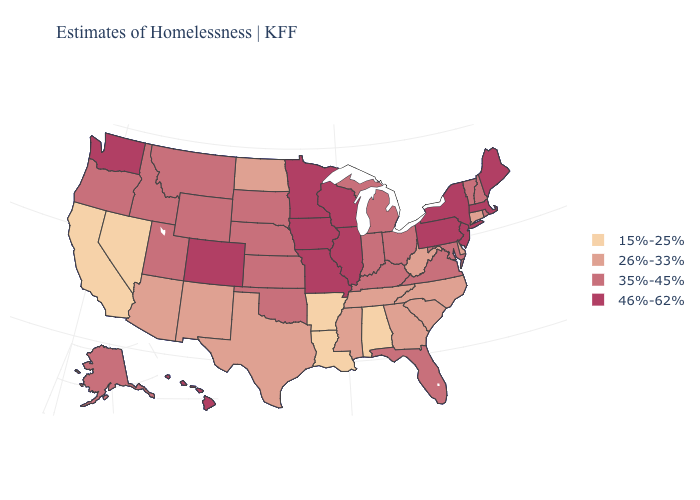Does the first symbol in the legend represent the smallest category?
Be succinct. Yes. What is the value of Delaware?
Concise answer only. 26%-33%. Does the first symbol in the legend represent the smallest category?
Answer briefly. Yes. Name the states that have a value in the range 26%-33%?
Quick response, please. Arizona, Connecticut, Delaware, Georgia, Mississippi, New Mexico, North Carolina, North Dakota, South Carolina, Tennessee, Texas, West Virginia. What is the value of Ohio?
Write a very short answer. 35%-45%. Name the states that have a value in the range 15%-25%?
Give a very brief answer. Alabama, Arkansas, California, Louisiana, Nevada. Name the states that have a value in the range 35%-45%?
Short answer required. Alaska, Florida, Idaho, Indiana, Kansas, Kentucky, Maryland, Michigan, Montana, Nebraska, New Hampshire, Ohio, Oklahoma, Oregon, Rhode Island, South Dakota, Utah, Vermont, Virginia, Wyoming. Does Wisconsin have the highest value in the USA?
Concise answer only. Yes. Among the states that border Idaho , does Washington have the lowest value?
Give a very brief answer. No. What is the value of Oklahoma?
Short answer required. 35%-45%. Which states hav the highest value in the Northeast?
Be succinct. Maine, Massachusetts, New Jersey, New York, Pennsylvania. Which states hav the highest value in the MidWest?
Concise answer only. Illinois, Iowa, Minnesota, Missouri, Wisconsin. What is the highest value in the South ?
Write a very short answer. 35%-45%. Name the states that have a value in the range 26%-33%?
Answer briefly. Arizona, Connecticut, Delaware, Georgia, Mississippi, New Mexico, North Carolina, North Dakota, South Carolina, Tennessee, Texas, West Virginia. Does Nevada have the lowest value in the USA?
Quick response, please. Yes. 